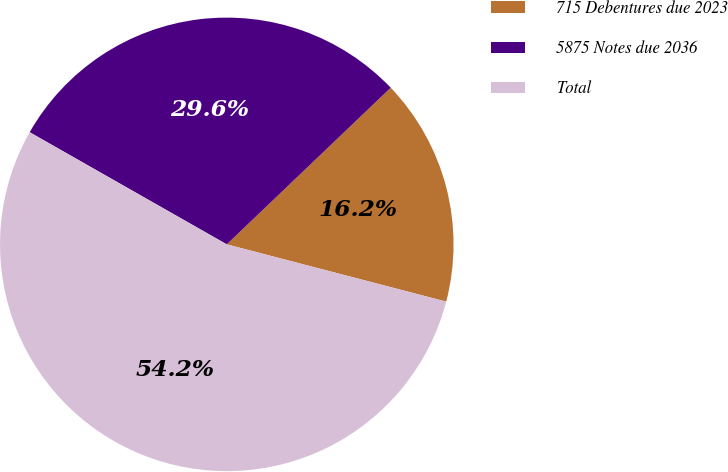Convert chart. <chart><loc_0><loc_0><loc_500><loc_500><pie_chart><fcel>715 Debentures due 2023<fcel>5875 Notes due 2036<fcel>Total<nl><fcel>16.2%<fcel>29.63%<fcel>54.17%<nl></chart> 